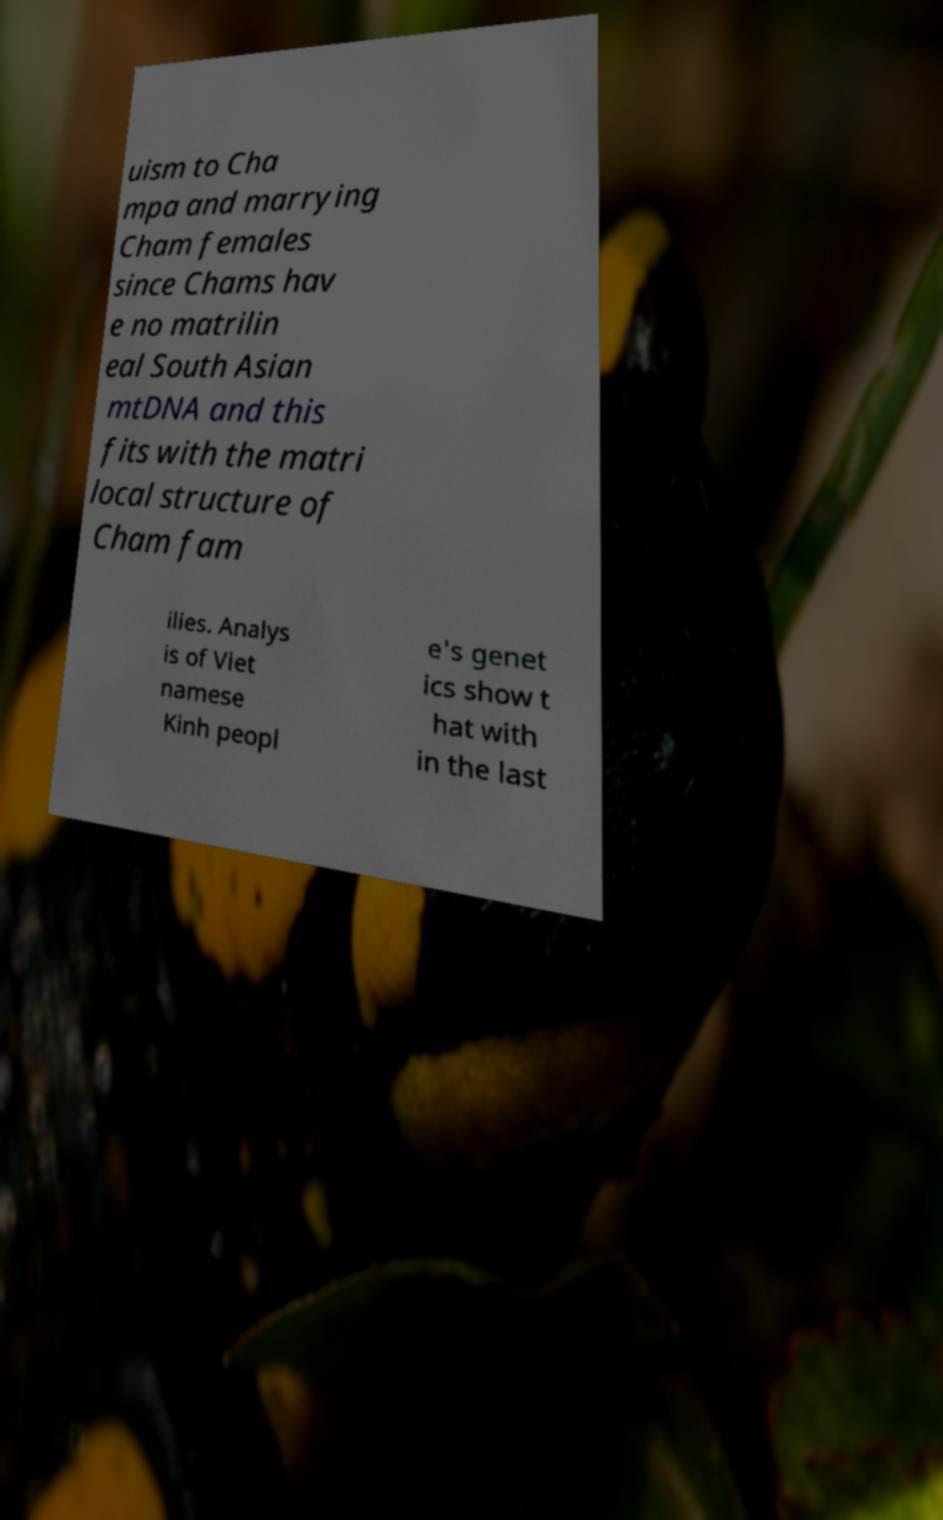Could you extract and type out the text from this image? uism to Cha mpa and marrying Cham females since Chams hav e no matrilin eal South Asian mtDNA and this fits with the matri local structure of Cham fam ilies. Analys is of Viet namese Kinh peopl e's genet ics show t hat with in the last 